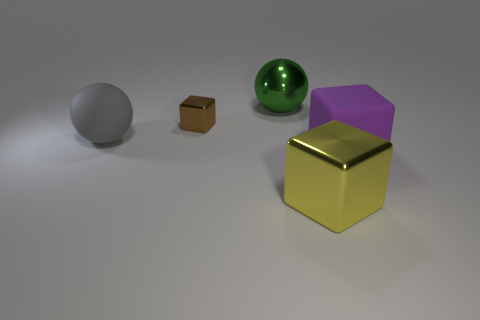Add 5 tiny red matte objects. How many objects exist? 10 Subtract all spheres. How many objects are left? 3 Subtract 0 red balls. How many objects are left? 5 Subtract all small metal objects. Subtract all large gray rubber objects. How many objects are left? 3 Add 5 large purple matte things. How many large purple matte things are left? 6 Add 4 yellow things. How many yellow things exist? 5 